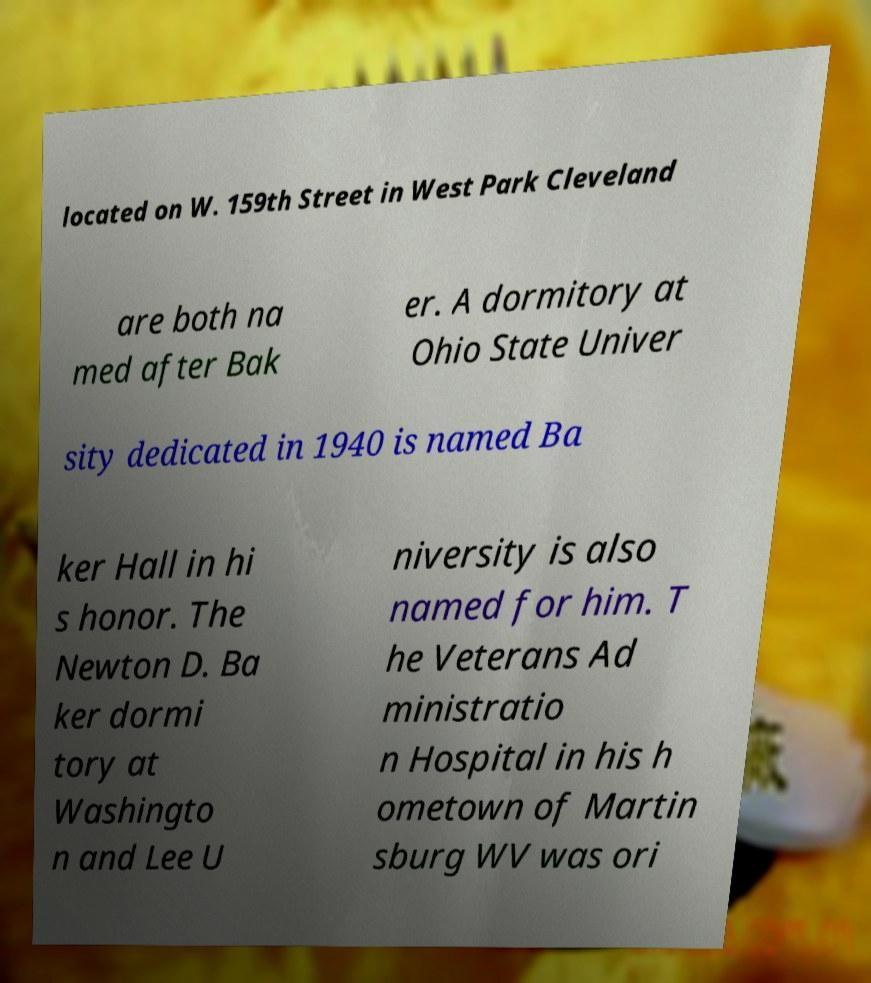I need the written content from this picture converted into text. Can you do that? located on W. 159th Street in West Park Cleveland are both na med after Bak er. A dormitory at Ohio State Univer sity dedicated in 1940 is named Ba ker Hall in hi s honor. The Newton D. Ba ker dormi tory at Washingto n and Lee U niversity is also named for him. T he Veterans Ad ministratio n Hospital in his h ometown of Martin sburg WV was ori 